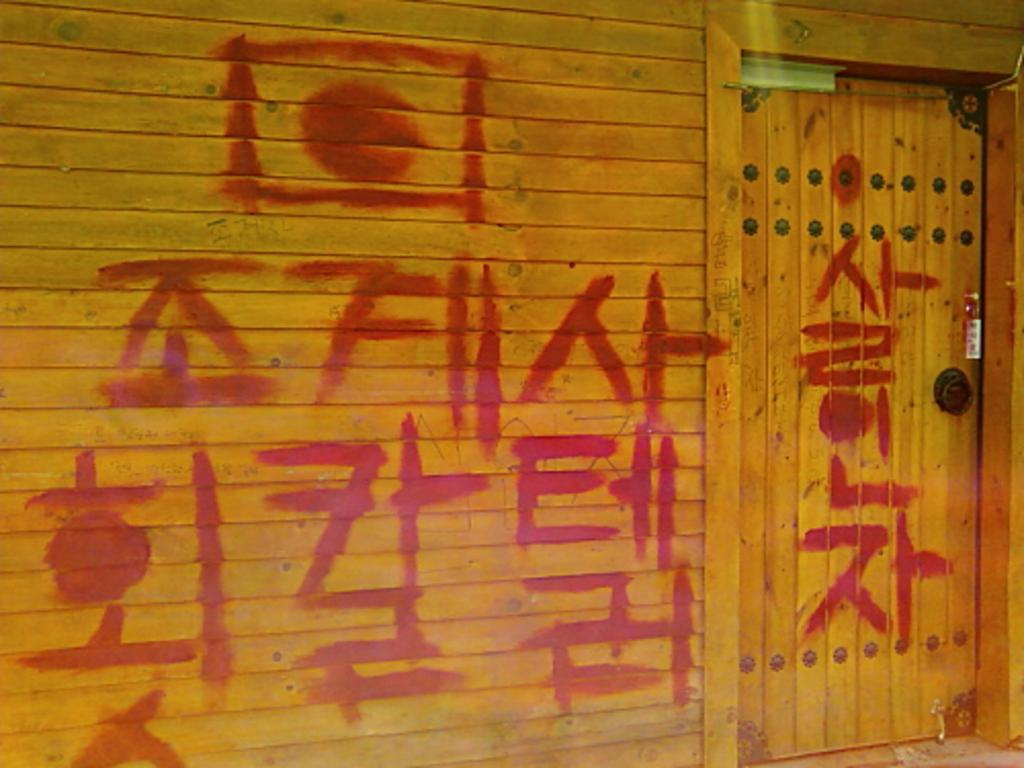What is the color and material of the wall in the image? The wall in the image is made of yellow wooden material. What can be found on the wall? There is a small door on the wall. How can you describe the door in the image? The small door has red color spray marks on it. What type of trees can be seen growing on the wall in the image? There are no trees visible on the wall in the image. How many drawers are present on the wall in the image? There are no drawers present on the wall in the image. 